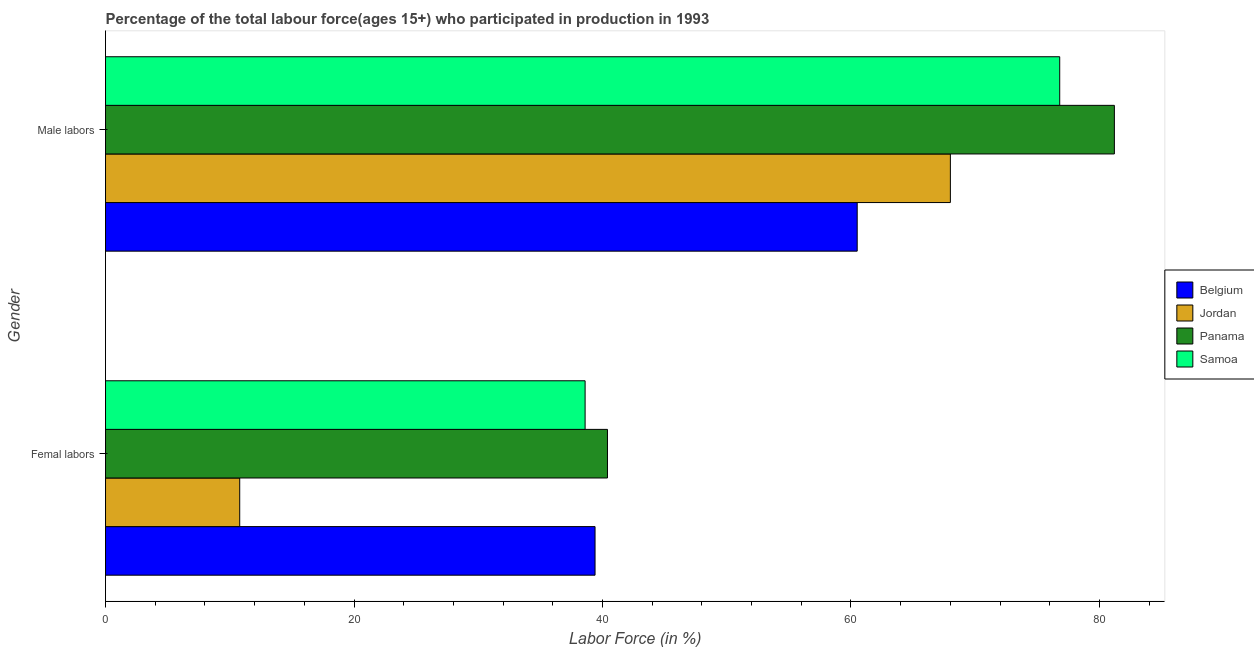How many different coloured bars are there?
Your answer should be compact. 4. How many groups of bars are there?
Your response must be concise. 2. Are the number of bars on each tick of the Y-axis equal?
Your answer should be very brief. Yes. How many bars are there on the 2nd tick from the bottom?
Keep it short and to the point. 4. What is the label of the 1st group of bars from the top?
Your response must be concise. Male labors. What is the percentage of female labor force in Panama?
Offer a terse response. 40.4. Across all countries, what is the maximum percentage of female labor force?
Your response must be concise. 40.4. Across all countries, what is the minimum percentage of female labor force?
Give a very brief answer. 10.8. In which country was the percentage of female labor force maximum?
Make the answer very short. Panama. What is the total percentage of female labor force in the graph?
Give a very brief answer. 129.2. What is the difference between the percentage of male labour force in Samoa and that in Jordan?
Offer a terse response. 8.8. What is the difference between the percentage of female labor force in Belgium and the percentage of male labour force in Jordan?
Provide a short and direct response. -28.6. What is the average percentage of female labor force per country?
Provide a succinct answer. 32.3. What is the difference between the percentage of male labour force and percentage of female labor force in Jordan?
Offer a very short reply. 57.2. In how many countries, is the percentage of female labor force greater than 20 %?
Ensure brevity in your answer.  3. What is the ratio of the percentage of female labor force in Jordan to that in Panama?
Provide a short and direct response. 0.27. Is the percentage of male labour force in Panama less than that in Samoa?
Make the answer very short. No. What does the 2nd bar from the top in Femal labors represents?
Give a very brief answer. Panama. Does the graph contain any zero values?
Make the answer very short. No. Does the graph contain grids?
Provide a succinct answer. No. Where does the legend appear in the graph?
Offer a terse response. Center right. How many legend labels are there?
Offer a very short reply. 4. How are the legend labels stacked?
Keep it short and to the point. Vertical. What is the title of the graph?
Offer a terse response. Percentage of the total labour force(ages 15+) who participated in production in 1993. Does "Madagascar" appear as one of the legend labels in the graph?
Ensure brevity in your answer.  No. What is the label or title of the X-axis?
Provide a succinct answer. Labor Force (in %). What is the label or title of the Y-axis?
Ensure brevity in your answer.  Gender. What is the Labor Force (in %) of Belgium in Femal labors?
Ensure brevity in your answer.  39.4. What is the Labor Force (in %) of Jordan in Femal labors?
Your answer should be compact. 10.8. What is the Labor Force (in %) in Panama in Femal labors?
Offer a terse response. 40.4. What is the Labor Force (in %) of Samoa in Femal labors?
Ensure brevity in your answer.  38.6. What is the Labor Force (in %) of Belgium in Male labors?
Your answer should be compact. 60.5. What is the Labor Force (in %) in Panama in Male labors?
Keep it short and to the point. 81.2. What is the Labor Force (in %) in Samoa in Male labors?
Make the answer very short. 76.8. Across all Gender, what is the maximum Labor Force (in %) of Belgium?
Provide a succinct answer. 60.5. Across all Gender, what is the maximum Labor Force (in %) in Jordan?
Offer a very short reply. 68. Across all Gender, what is the maximum Labor Force (in %) of Panama?
Provide a succinct answer. 81.2. Across all Gender, what is the maximum Labor Force (in %) in Samoa?
Your answer should be very brief. 76.8. Across all Gender, what is the minimum Labor Force (in %) of Belgium?
Your response must be concise. 39.4. Across all Gender, what is the minimum Labor Force (in %) of Jordan?
Ensure brevity in your answer.  10.8. Across all Gender, what is the minimum Labor Force (in %) in Panama?
Provide a short and direct response. 40.4. Across all Gender, what is the minimum Labor Force (in %) in Samoa?
Make the answer very short. 38.6. What is the total Labor Force (in %) in Belgium in the graph?
Your answer should be compact. 99.9. What is the total Labor Force (in %) of Jordan in the graph?
Give a very brief answer. 78.8. What is the total Labor Force (in %) in Panama in the graph?
Your answer should be compact. 121.6. What is the total Labor Force (in %) in Samoa in the graph?
Give a very brief answer. 115.4. What is the difference between the Labor Force (in %) of Belgium in Femal labors and that in Male labors?
Make the answer very short. -21.1. What is the difference between the Labor Force (in %) of Jordan in Femal labors and that in Male labors?
Keep it short and to the point. -57.2. What is the difference between the Labor Force (in %) in Panama in Femal labors and that in Male labors?
Offer a terse response. -40.8. What is the difference between the Labor Force (in %) of Samoa in Femal labors and that in Male labors?
Keep it short and to the point. -38.2. What is the difference between the Labor Force (in %) in Belgium in Femal labors and the Labor Force (in %) in Jordan in Male labors?
Give a very brief answer. -28.6. What is the difference between the Labor Force (in %) of Belgium in Femal labors and the Labor Force (in %) of Panama in Male labors?
Provide a short and direct response. -41.8. What is the difference between the Labor Force (in %) in Belgium in Femal labors and the Labor Force (in %) in Samoa in Male labors?
Your response must be concise. -37.4. What is the difference between the Labor Force (in %) in Jordan in Femal labors and the Labor Force (in %) in Panama in Male labors?
Give a very brief answer. -70.4. What is the difference between the Labor Force (in %) of Jordan in Femal labors and the Labor Force (in %) of Samoa in Male labors?
Offer a very short reply. -66. What is the difference between the Labor Force (in %) in Panama in Femal labors and the Labor Force (in %) in Samoa in Male labors?
Offer a very short reply. -36.4. What is the average Labor Force (in %) in Belgium per Gender?
Offer a terse response. 49.95. What is the average Labor Force (in %) in Jordan per Gender?
Offer a terse response. 39.4. What is the average Labor Force (in %) in Panama per Gender?
Your answer should be compact. 60.8. What is the average Labor Force (in %) of Samoa per Gender?
Your answer should be compact. 57.7. What is the difference between the Labor Force (in %) in Belgium and Labor Force (in %) in Jordan in Femal labors?
Make the answer very short. 28.6. What is the difference between the Labor Force (in %) in Belgium and Labor Force (in %) in Panama in Femal labors?
Your answer should be very brief. -1. What is the difference between the Labor Force (in %) in Belgium and Labor Force (in %) in Samoa in Femal labors?
Your response must be concise. 0.8. What is the difference between the Labor Force (in %) in Jordan and Labor Force (in %) in Panama in Femal labors?
Offer a very short reply. -29.6. What is the difference between the Labor Force (in %) in Jordan and Labor Force (in %) in Samoa in Femal labors?
Your response must be concise. -27.8. What is the difference between the Labor Force (in %) in Belgium and Labor Force (in %) in Panama in Male labors?
Your response must be concise. -20.7. What is the difference between the Labor Force (in %) in Belgium and Labor Force (in %) in Samoa in Male labors?
Offer a terse response. -16.3. What is the difference between the Labor Force (in %) of Jordan and Labor Force (in %) of Samoa in Male labors?
Offer a terse response. -8.8. What is the difference between the Labor Force (in %) of Panama and Labor Force (in %) of Samoa in Male labors?
Your answer should be compact. 4.4. What is the ratio of the Labor Force (in %) in Belgium in Femal labors to that in Male labors?
Provide a short and direct response. 0.65. What is the ratio of the Labor Force (in %) of Jordan in Femal labors to that in Male labors?
Keep it short and to the point. 0.16. What is the ratio of the Labor Force (in %) of Panama in Femal labors to that in Male labors?
Give a very brief answer. 0.5. What is the ratio of the Labor Force (in %) in Samoa in Femal labors to that in Male labors?
Your answer should be compact. 0.5. What is the difference between the highest and the second highest Labor Force (in %) of Belgium?
Your response must be concise. 21.1. What is the difference between the highest and the second highest Labor Force (in %) of Jordan?
Provide a short and direct response. 57.2. What is the difference between the highest and the second highest Labor Force (in %) in Panama?
Offer a terse response. 40.8. What is the difference between the highest and the second highest Labor Force (in %) in Samoa?
Offer a terse response. 38.2. What is the difference between the highest and the lowest Labor Force (in %) of Belgium?
Provide a short and direct response. 21.1. What is the difference between the highest and the lowest Labor Force (in %) of Jordan?
Make the answer very short. 57.2. What is the difference between the highest and the lowest Labor Force (in %) of Panama?
Offer a very short reply. 40.8. What is the difference between the highest and the lowest Labor Force (in %) of Samoa?
Provide a succinct answer. 38.2. 